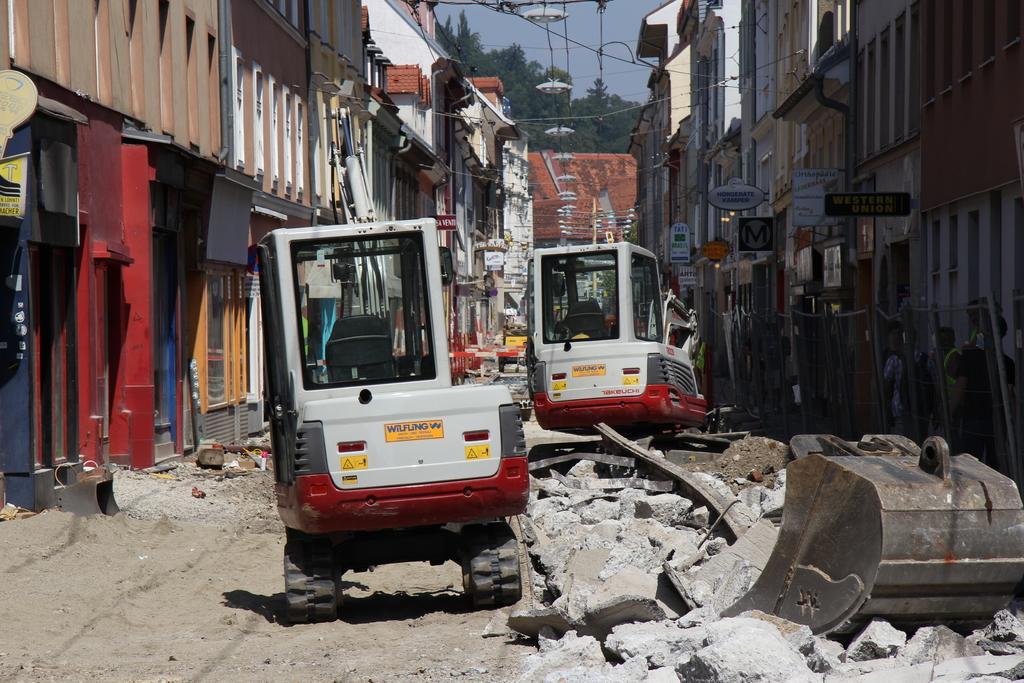Please provide a concise description of this image. In this picture I can see couple of cranes and few buildings and trees and I can see few rocks and a cloudy sky. 